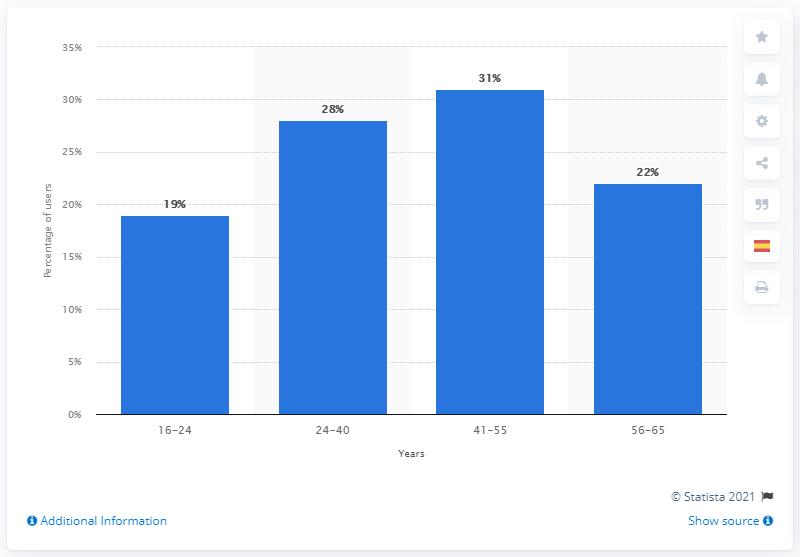Indicate a few pertinent items in this graphic. According to data, 19% of Spanish WhatsApp users were within the age group of 16-24. In 2020, approximately 31% of Spanish WhatsApp users were between the ages of 41 and 55. 